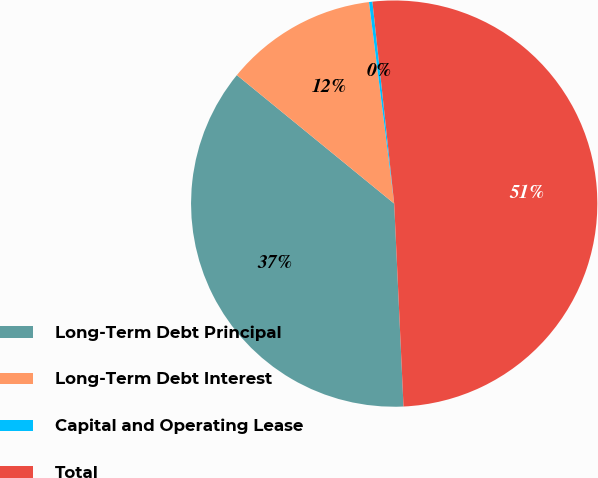Convert chart. <chart><loc_0><loc_0><loc_500><loc_500><pie_chart><fcel>Long-Term Debt Principal<fcel>Long-Term Debt Interest<fcel>Capital and Operating Lease<fcel>Total<nl><fcel>36.63%<fcel>12.12%<fcel>0.27%<fcel>50.98%<nl></chart> 